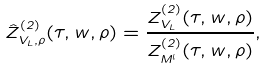<formula> <loc_0><loc_0><loc_500><loc_500>\hat { Z } _ { V _ { L } , \rho } ^ { ( 2 ) } ( \tau , w , \rho ) = \frac { Z _ { V _ { L } } ^ { ( 2 ) } ( \tau , w , \rho ) } { Z _ { M ^ { l } } ^ { ( 2 ) } ( \tau , w , \rho ) } ,</formula> 